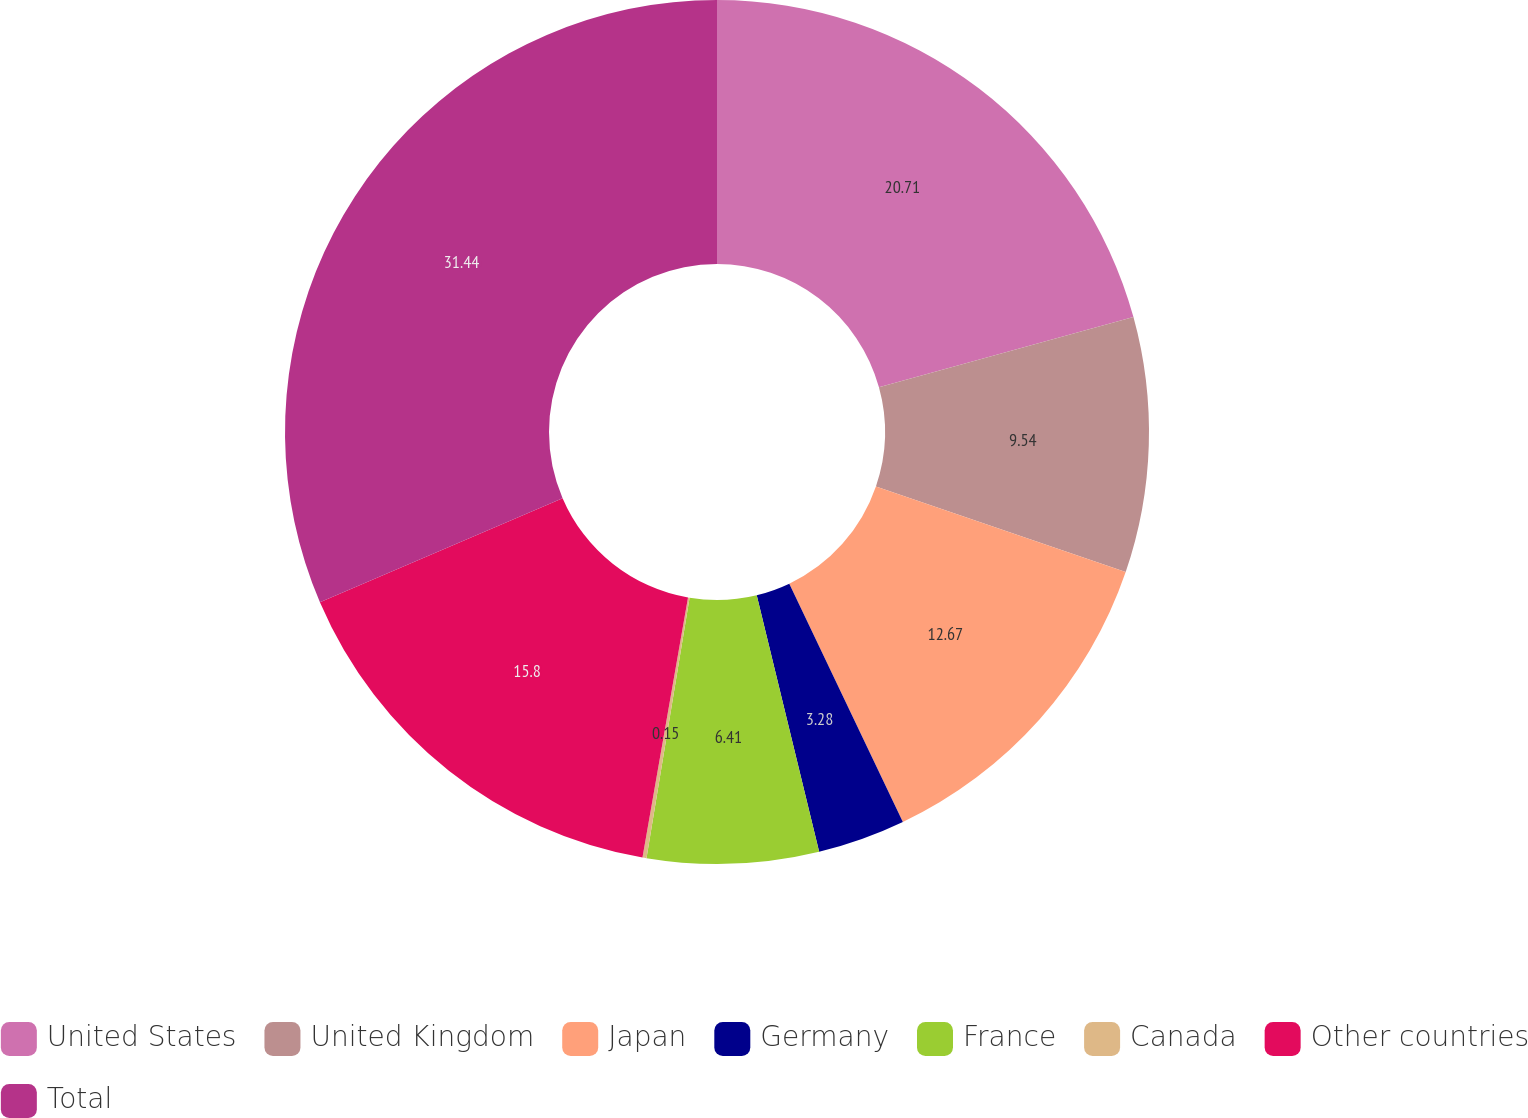Convert chart. <chart><loc_0><loc_0><loc_500><loc_500><pie_chart><fcel>United States<fcel>United Kingdom<fcel>Japan<fcel>Germany<fcel>France<fcel>Canada<fcel>Other countries<fcel>Total<nl><fcel>20.72%<fcel>9.54%<fcel>12.67%<fcel>3.28%<fcel>6.41%<fcel>0.15%<fcel>15.8%<fcel>31.45%<nl></chart> 